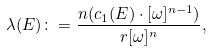Convert formula to latex. <formula><loc_0><loc_0><loc_500><loc_500>\lambda ( E ) \colon = \frac { n ( c _ { 1 } ( E ) \cdot [ \omega ] ^ { n - 1 } ) } { r [ \omega ] ^ { n } } ,</formula> 